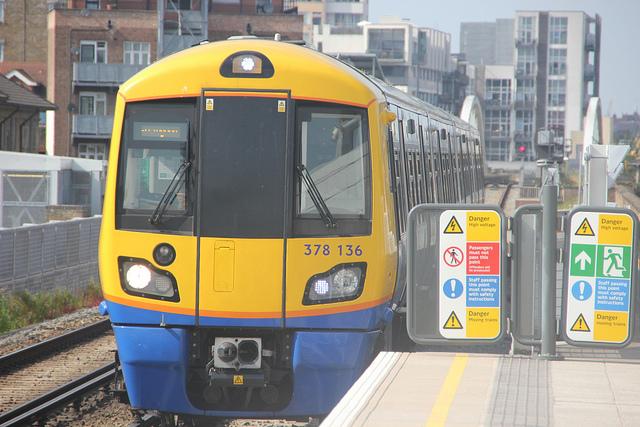Do you need a ticket to board this vehicle?
Be succinct. Yes. Where is the train?
Concise answer only. On tracks. How many warning signs?
Quick response, please. 2. 